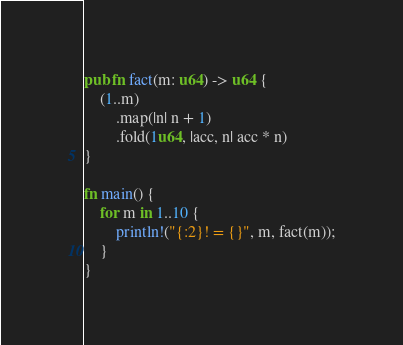Convert code to text. <code><loc_0><loc_0><loc_500><loc_500><_Rust_>pub fn fact(m: u64) -> u64 {
    (1..m)
        .map(|n| n + 1)
        .fold(1u64, |acc, n| acc * n)
}

fn main() {
    for m in 1..10 {
        println!("{:2}! = {}", m, fact(m));
    }
}
</code> 